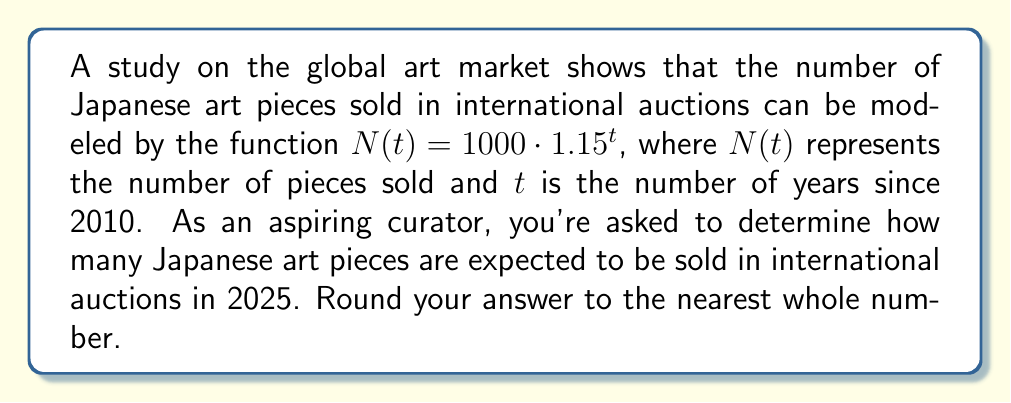Solve this math problem. To solve this problem, we need to follow these steps:

1. Identify the given information:
   - The function modeling the number of Japanese art pieces sold is $N(t) = 1000 \cdot 1.15^t$
   - $t$ represents the number of years since 2010
   - We need to find the number of pieces sold in 2025

2. Calculate the value of $t$ for the year 2025:
   - 2025 is 15 years after 2010
   - Therefore, $t = 15$

3. Substitute $t = 15$ into the given function:
   $N(15) = 1000 \cdot 1.15^{15}$

4. Calculate the result:
   $N(15) = 1000 \cdot 1.15^{15}$
   $= 1000 \cdot 8.13704461$
   $= 8137.04461$

5. Round the result to the nearest whole number:
   8137.04461 rounds to 8137

Therefore, in 2025, approximately 8137 Japanese art pieces are expected to be sold in international auctions.
Answer: 8137 